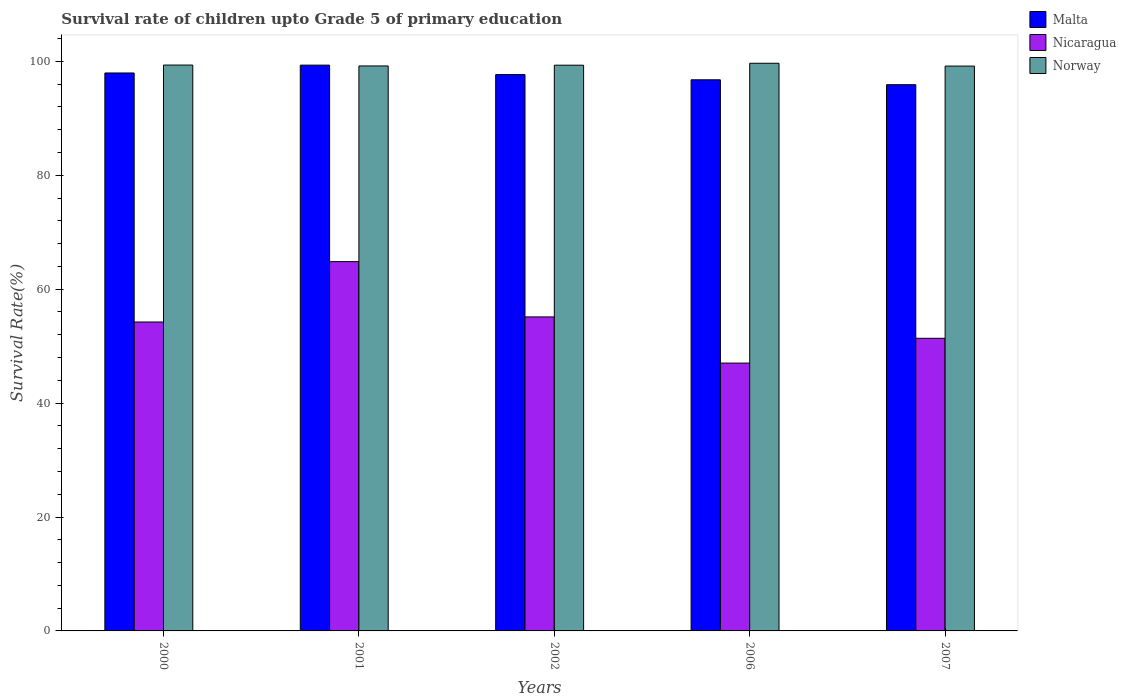How many different coloured bars are there?
Your answer should be compact. 3. Are the number of bars per tick equal to the number of legend labels?
Your answer should be very brief. Yes. How many bars are there on the 2nd tick from the left?
Your answer should be compact. 3. What is the label of the 5th group of bars from the left?
Offer a terse response. 2007. What is the survival rate of children in Norway in 2002?
Provide a succinct answer. 99.33. Across all years, what is the maximum survival rate of children in Malta?
Provide a short and direct response. 99.34. Across all years, what is the minimum survival rate of children in Nicaragua?
Offer a terse response. 47.02. In which year was the survival rate of children in Norway minimum?
Your response must be concise. 2007. What is the total survival rate of children in Malta in the graph?
Provide a short and direct response. 487.64. What is the difference between the survival rate of children in Nicaragua in 2006 and that in 2007?
Keep it short and to the point. -4.35. What is the difference between the survival rate of children in Nicaragua in 2000 and the survival rate of children in Norway in 2006?
Your answer should be very brief. -45.43. What is the average survival rate of children in Nicaragua per year?
Provide a short and direct response. 54.52. In the year 2000, what is the difference between the survival rate of children in Nicaragua and survival rate of children in Norway?
Your answer should be very brief. -45.11. What is the ratio of the survival rate of children in Norway in 2001 to that in 2007?
Provide a short and direct response. 1. What is the difference between the highest and the second highest survival rate of children in Norway?
Your answer should be very brief. 0.32. What is the difference between the highest and the lowest survival rate of children in Nicaragua?
Keep it short and to the point. 17.81. In how many years, is the survival rate of children in Malta greater than the average survival rate of children in Malta taken over all years?
Provide a short and direct response. 3. What does the 1st bar from the left in 2006 represents?
Your answer should be compact. Malta. How many years are there in the graph?
Your response must be concise. 5. What is the difference between two consecutive major ticks on the Y-axis?
Your answer should be very brief. 20. Are the values on the major ticks of Y-axis written in scientific E-notation?
Make the answer very short. No. Does the graph contain grids?
Offer a very short reply. No. How many legend labels are there?
Offer a terse response. 3. How are the legend labels stacked?
Your answer should be compact. Vertical. What is the title of the graph?
Offer a terse response. Survival rate of children upto Grade 5 of primary education. Does "Least developed countries" appear as one of the legend labels in the graph?
Keep it short and to the point. No. What is the label or title of the Y-axis?
Your response must be concise. Survival Rate(%). What is the Survival Rate(%) of Malta in 2000?
Your response must be concise. 97.96. What is the Survival Rate(%) in Nicaragua in 2000?
Offer a terse response. 54.24. What is the Survival Rate(%) in Norway in 2000?
Your response must be concise. 99.35. What is the Survival Rate(%) in Malta in 2001?
Provide a succinct answer. 99.34. What is the Survival Rate(%) in Nicaragua in 2001?
Your answer should be very brief. 64.84. What is the Survival Rate(%) in Norway in 2001?
Your answer should be very brief. 99.19. What is the Survival Rate(%) of Malta in 2002?
Offer a terse response. 97.68. What is the Survival Rate(%) in Nicaragua in 2002?
Give a very brief answer. 55.13. What is the Survival Rate(%) of Norway in 2002?
Your response must be concise. 99.33. What is the Survival Rate(%) in Malta in 2006?
Keep it short and to the point. 96.76. What is the Survival Rate(%) in Nicaragua in 2006?
Provide a succinct answer. 47.02. What is the Survival Rate(%) in Norway in 2006?
Provide a short and direct response. 99.67. What is the Survival Rate(%) of Malta in 2007?
Keep it short and to the point. 95.9. What is the Survival Rate(%) in Nicaragua in 2007?
Your answer should be very brief. 51.38. What is the Survival Rate(%) of Norway in 2007?
Your answer should be very brief. 99.17. Across all years, what is the maximum Survival Rate(%) of Malta?
Your answer should be very brief. 99.34. Across all years, what is the maximum Survival Rate(%) in Nicaragua?
Your answer should be compact. 64.84. Across all years, what is the maximum Survival Rate(%) in Norway?
Offer a terse response. 99.67. Across all years, what is the minimum Survival Rate(%) in Malta?
Provide a succinct answer. 95.9. Across all years, what is the minimum Survival Rate(%) of Nicaragua?
Your response must be concise. 47.02. Across all years, what is the minimum Survival Rate(%) in Norway?
Make the answer very short. 99.17. What is the total Survival Rate(%) in Malta in the graph?
Your answer should be compact. 487.64. What is the total Survival Rate(%) in Nicaragua in the graph?
Your answer should be very brief. 272.61. What is the total Survival Rate(%) in Norway in the graph?
Provide a succinct answer. 496.71. What is the difference between the Survival Rate(%) of Malta in 2000 and that in 2001?
Keep it short and to the point. -1.38. What is the difference between the Survival Rate(%) in Nicaragua in 2000 and that in 2001?
Make the answer very short. -10.6. What is the difference between the Survival Rate(%) in Norway in 2000 and that in 2001?
Make the answer very short. 0.16. What is the difference between the Survival Rate(%) in Malta in 2000 and that in 2002?
Offer a very short reply. 0.28. What is the difference between the Survival Rate(%) of Nicaragua in 2000 and that in 2002?
Offer a very short reply. -0.9. What is the difference between the Survival Rate(%) in Norway in 2000 and that in 2002?
Keep it short and to the point. 0.02. What is the difference between the Survival Rate(%) of Malta in 2000 and that in 2006?
Your answer should be compact. 1.2. What is the difference between the Survival Rate(%) of Nicaragua in 2000 and that in 2006?
Provide a succinct answer. 7.21. What is the difference between the Survival Rate(%) of Norway in 2000 and that in 2006?
Provide a succinct answer. -0.32. What is the difference between the Survival Rate(%) in Malta in 2000 and that in 2007?
Your answer should be very brief. 2.06. What is the difference between the Survival Rate(%) in Nicaragua in 2000 and that in 2007?
Give a very brief answer. 2.86. What is the difference between the Survival Rate(%) of Norway in 2000 and that in 2007?
Offer a terse response. 0.18. What is the difference between the Survival Rate(%) in Malta in 2001 and that in 2002?
Your answer should be very brief. 1.66. What is the difference between the Survival Rate(%) of Nicaragua in 2001 and that in 2002?
Ensure brevity in your answer.  9.71. What is the difference between the Survival Rate(%) of Norway in 2001 and that in 2002?
Provide a succinct answer. -0.13. What is the difference between the Survival Rate(%) of Malta in 2001 and that in 2006?
Your answer should be very brief. 2.57. What is the difference between the Survival Rate(%) in Nicaragua in 2001 and that in 2006?
Provide a succinct answer. 17.81. What is the difference between the Survival Rate(%) in Norway in 2001 and that in 2006?
Keep it short and to the point. -0.47. What is the difference between the Survival Rate(%) of Malta in 2001 and that in 2007?
Provide a short and direct response. 3.43. What is the difference between the Survival Rate(%) of Nicaragua in 2001 and that in 2007?
Provide a short and direct response. 13.46. What is the difference between the Survival Rate(%) of Norway in 2001 and that in 2007?
Your response must be concise. 0.02. What is the difference between the Survival Rate(%) in Malta in 2002 and that in 2006?
Provide a succinct answer. 0.91. What is the difference between the Survival Rate(%) of Nicaragua in 2002 and that in 2006?
Ensure brevity in your answer.  8.11. What is the difference between the Survival Rate(%) of Norway in 2002 and that in 2006?
Ensure brevity in your answer.  -0.34. What is the difference between the Survival Rate(%) in Malta in 2002 and that in 2007?
Keep it short and to the point. 1.77. What is the difference between the Survival Rate(%) of Nicaragua in 2002 and that in 2007?
Your response must be concise. 3.76. What is the difference between the Survival Rate(%) of Norway in 2002 and that in 2007?
Offer a very short reply. 0.16. What is the difference between the Survival Rate(%) in Malta in 2006 and that in 2007?
Keep it short and to the point. 0.86. What is the difference between the Survival Rate(%) of Nicaragua in 2006 and that in 2007?
Provide a short and direct response. -4.35. What is the difference between the Survival Rate(%) in Norway in 2006 and that in 2007?
Your answer should be very brief. 0.5. What is the difference between the Survival Rate(%) in Malta in 2000 and the Survival Rate(%) in Nicaragua in 2001?
Ensure brevity in your answer.  33.12. What is the difference between the Survival Rate(%) in Malta in 2000 and the Survival Rate(%) in Norway in 2001?
Your answer should be very brief. -1.23. What is the difference between the Survival Rate(%) of Nicaragua in 2000 and the Survival Rate(%) of Norway in 2001?
Make the answer very short. -44.96. What is the difference between the Survival Rate(%) in Malta in 2000 and the Survival Rate(%) in Nicaragua in 2002?
Offer a terse response. 42.83. What is the difference between the Survival Rate(%) of Malta in 2000 and the Survival Rate(%) of Norway in 2002?
Give a very brief answer. -1.37. What is the difference between the Survival Rate(%) of Nicaragua in 2000 and the Survival Rate(%) of Norway in 2002?
Offer a terse response. -45.09. What is the difference between the Survival Rate(%) of Malta in 2000 and the Survival Rate(%) of Nicaragua in 2006?
Make the answer very short. 50.93. What is the difference between the Survival Rate(%) in Malta in 2000 and the Survival Rate(%) in Norway in 2006?
Give a very brief answer. -1.71. What is the difference between the Survival Rate(%) of Nicaragua in 2000 and the Survival Rate(%) of Norway in 2006?
Make the answer very short. -45.43. What is the difference between the Survival Rate(%) of Malta in 2000 and the Survival Rate(%) of Nicaragua in 2007?
Your response must be concise. 46.58. What is the difference between the Survival Rate(%) of Malta in 2000 and the Survival Rate(%) of Norway in 2007?
Provide a succinct answer. -1.21. What is the difference between the Survival Rate(%) of Nicaragua in 2000 and the Survival Rate(%) of Norway in 2007?
Ensure brevity in your answer.  -44.93. What is the difference between the Survival Rate(%) of Malta in 2001 and the Survival Rate(%) of Nicaragua in 2002?
Offer a terse response. 44.2. What is the difference between the Survival Rate(%) in Malta in 2001 and the Survival Rate(%) in Norway in 2002?
Make the answer very short. 0.01. What is the difference between the Survival Rate(%) of Nicaragua in 2001 and the Survival Rate(%) of Norway in 2002?
Give a very brief answer. -34.49. What is the difference between the Survival Rate(%) of Malta in 2001 and the Survival Rate(%) of Nicaragua in 2006?
Provide a short and direct response. 52.31. What is the difference between the Survival Rate(%) of Malta in 2001 and the Survival Rate(%) of Norway in 2006?
Offer a terse response. -0.33. What is the difference between the Survival Rate(%) of Nicaragua in 2001 and the Survival Rate(%) of Norway in 2006?
Your response must be concise. -34.83. What is the difference between the Survival Rate(%) in Malta in 2001 and the Survival Rate(%) in Nicaragua in 2007?
Provide a succinct answer. 47.96. What is the difference between the Survival Rate(%) in Malta in 2001 and the Survival Rate(%) in Norway in 2007?
Offer a very short reply. 0.17. What is the difference between the Survival Rate(%) of Nicaragua in 2001 and the Survival Rate(%) of Norway in 2007?
Give a very brief answer. -34.33. What is the difference between the Survival Rate(%) in Malta in 2002 and the Survival Rate(%) in Nicaragua in 2006?
Your answer should be compact. 50.65. What is the difference between the Survival Rate(%) of Malta in 2002 and the Survival Rate(%) of Norway in 2006?
Keep it short and to the point. -1.99. What is the difference between the Survival Rate(%) of Nicaragua in 2002 and the Survival Rate(%) of Norway in 2006?
Provide a short and direct response. -44.53. What is the difference between the Survival Rate(%) in Malta in 2002 and the Survival Rate(%) in Nicaragua in 2007?
Offer a very short reply. 46.3. What is the difference between the Survival Rate(%) of Malta in 2002 and the Survival Rate(%) of Norway in 2007?
Your response must be concise. -1.49. What is the difference between the Survival Rate(%) in Nicaragua in 2002 and the Survival Rate(%) in Norway in 2007?
Keep it short and to the point. -44.04. What is the difference between the Survival Rate(%) in Malta in 2006 and the Survival Rate(%) in Nicaragua in 2007?
Provide a short and direct response. 45.39. What is the difference between the Survival Rate(%) in Malta in 2006 and the Survival Rate(%) in Norway in 2007?
Your response must be concise. -2.41. What is the difference between the Survival Rate(%) of Nicaragua in 2006 and the Survival Rate(%) of Norway in 2007?
Ensure brevity in your answer.  -52.15. What is the average Survival Rate(%) of Malta per year?
Keep it short and to the point. 97.53. What is the average Survival Rate(%) of Nicaragua per year?
Your answer should be very brief. 54.52. What is the average Survival Rate(%) of Norway per year?
Keep it short and to the point. 99.34. In the year 2000, what is the difference between the Survival Rate(%) of Malta and Survival Rate(%) of Nicaragua?
Your response must be concise. 43.72. In the year 2000, what is the difference between the Survival Rate(%) in Malta and Survival Rate(%) in Norway?
Offer a very short reply. -1.39. In the year 2000, what is the difference between the Survival Rate(%) in Nicaragua and Survival Rate(%) in Norway?
Provide a succinct answer. -45.11. In the year 2001, what is the difference between the Survival Rate(%) in Malta and Survival Rate(%) in Nicaragua?
Offer a terse response. 34.5. In the year 2001, what is the difference between the Survival Rate(%) in Malta and Survival Rate(%) in Norway?
Offer a terse response. 0.14. In the year 2001, what is the difference between the Survival Rate(%) of Nicaragua and Survival Rate(%) of Norway?
Provide a short and direct response. -34.36. In the year 2002, what is the difference between the Survival Rate(%) of Malta and Survival Rate(%) of Nicaragua?
Offer a very short reply. 42.54. In the year 2002, what is the difference between the Survival Rate(%) in Malta and Survival Rate(%) in Norway?
Your answer should be very brief. -1.65. In the year 2002, what is the difference between the Survival Rate(%) in Nicaragua and Survival Rate(%) in Norway?
Your answer should be compact. -44.19. In the year 2006, what is the difference between the Survival Rate(%) in Malta and Survival Rate(%) in Nicaragua?
Your response must be concise. 49.74. In the year 2006, what is the difference between the Survival Rate(%) of Malta and Survival Rate(%) of Norway?
Ensure brevity in your answer.  -2.9. In the year 2006, what is the difference between the Survival Rate(%) in Nicaragua and Survival Rate(%) in Norway?
Your answer should be compact. -52.64. In the year 2007, what is the difference between the Survival Rate(%) of Malta and Survival Rate(%) of Nicaragua?
Keep it short and to the point. 44.53. In the year 2007, what is the difference between the Survival Rate(%) in Malta and Survival Rate(%) in Norway?
Ensure brevity in your answer.  -3.27. In the year 2007, what is the difference between the Survival Rate(%) in Nicaragua and Survival Rate(%) in Norway?
Provide a succinct answer. -47.8. What is the ratio of the Survival Rate(%) of Malta in 2000 to that in 2001?
Ensure brevity in your answer.  0.99. What is the ratio of the Survival Rate(%) in Nicaragua in 2000 to that in 2001?
Offer a very short reply. 0.84. What is the ratio of the Survival Rate(%) in Norway in 2000 to that in 2001?
Make the answer very short. 1. What is the ratio of the Survival Rate(%) of Nicaragua in 2000 to that in 2002?
Your answer should be very brief. 0.98. What is the ratio of the Survival Rate(%) in Norway in 2000 to that in 2002?
Give a very brief answer. 1. What is the ratio of the Survival Rate(%) of Malta in 2000 to that in 2006?
Your answer should be very brief. 1.01. What is the ratio of the Survival Rate(%) in Nicaragua in 2000 to that in 2006?
Keep it short and to the point. 1.15. What is the ratio of the Survival Rate(%) of Norway in 2000 to that in 2006?
Your answer should be compact. 1. What is the ratio of the Survival Rate(%) of Malta in 2000 to that in 2007?
Your response must be concise. 1.02. What is the ratio of the Survival Rate(%) of Nicaragua in 2000 to that in 2007?
Your answer should be very brief. 1.06. What is the ratio of the Survival Rate(%) of Norway in 2000 to that in 2007?
Give a very brief answer. 1. What is the ratio of the Survival Rate(%) of Nicaragua in 2001 to that in 2002?
Your answer should be compact. 1.18. What is the ratio of the Survival Rate(%) in Malta in 2001 to that in 2006?
Offer a terse response. 1.03. What is the ratio of the Survival Rate(%) of Nicaragua in 2001 to that in 2006?
Ensure brevity in your answer.  1.38. What is the ratio of the Survival Rate(%) in Norway in 2001 to that in 2006?
Make the answer very short. 1. What is the ratio of the Survival Rate(%) of Malta in 2001 to that in 2007?
Offer a very short reply. 1.04. What is the ratio of the Survival Rate(%) in Nicaragua in 2001 to that in 2007?
Make the answer very short. 1.26. What is the ratio of the Survival Rate(%) in Malta in 2002 to that in 2006?
Offer a terse response. 1.01. What is the ratio of the Survival Rate(%) in Nicaragua in 2002 to that in 2006?
Your response must be concise. 1.17. What is the ratio of the Survival Rate(%) in Norway in 2002 to that in 2006?
Give a very brief answer. 1. What is the ratio of the Survival Rate(%) in Malta in 2002 to that in 2007?
Make the answer very short. 1.02. What is the ratio of the Survival Rate(%) in Nicaragua in 2002 to that in 2007?
Keep it short and to the point. 1.07. What is the ratio of the Survival Rate(%) in Norway in 2002 to that in 2007?
Your answer should be compact. 1. What is the ratio of the Survival Rate(%) of Malta in 2006 to that in 2007?
Ensure brevity in your answer.  1.01. What is the ratio of the Survival Rate(%) in Nicaragua in 2006 to that in 2007?
Your answer should be very brief. 0.92. What is the difference between the highest and the second highest Survival Rate(%) in Malta?
Offer a terse response. 1.38. What is the difference between the highest and the second highest Survival Rate(%) in Nicaragua?
Your response must be concise. 9.71. What is the difference between the highest and the second highest Survival Rate(%) in Norway?
Provide a succinct answer. 0.32. What is the difference between the highest and the lowest Survival Rate(%) in Malta?
Keep it short and to the point. 3.43. What is the difference between the highest and the lowest Survival Rate(%) of Nicaragua?
Give a very brief answer. 17.81. What is the difference between the highest and the lowest Survival Rate(%) of Norway?
Keep it short and to the point. 0.5. 